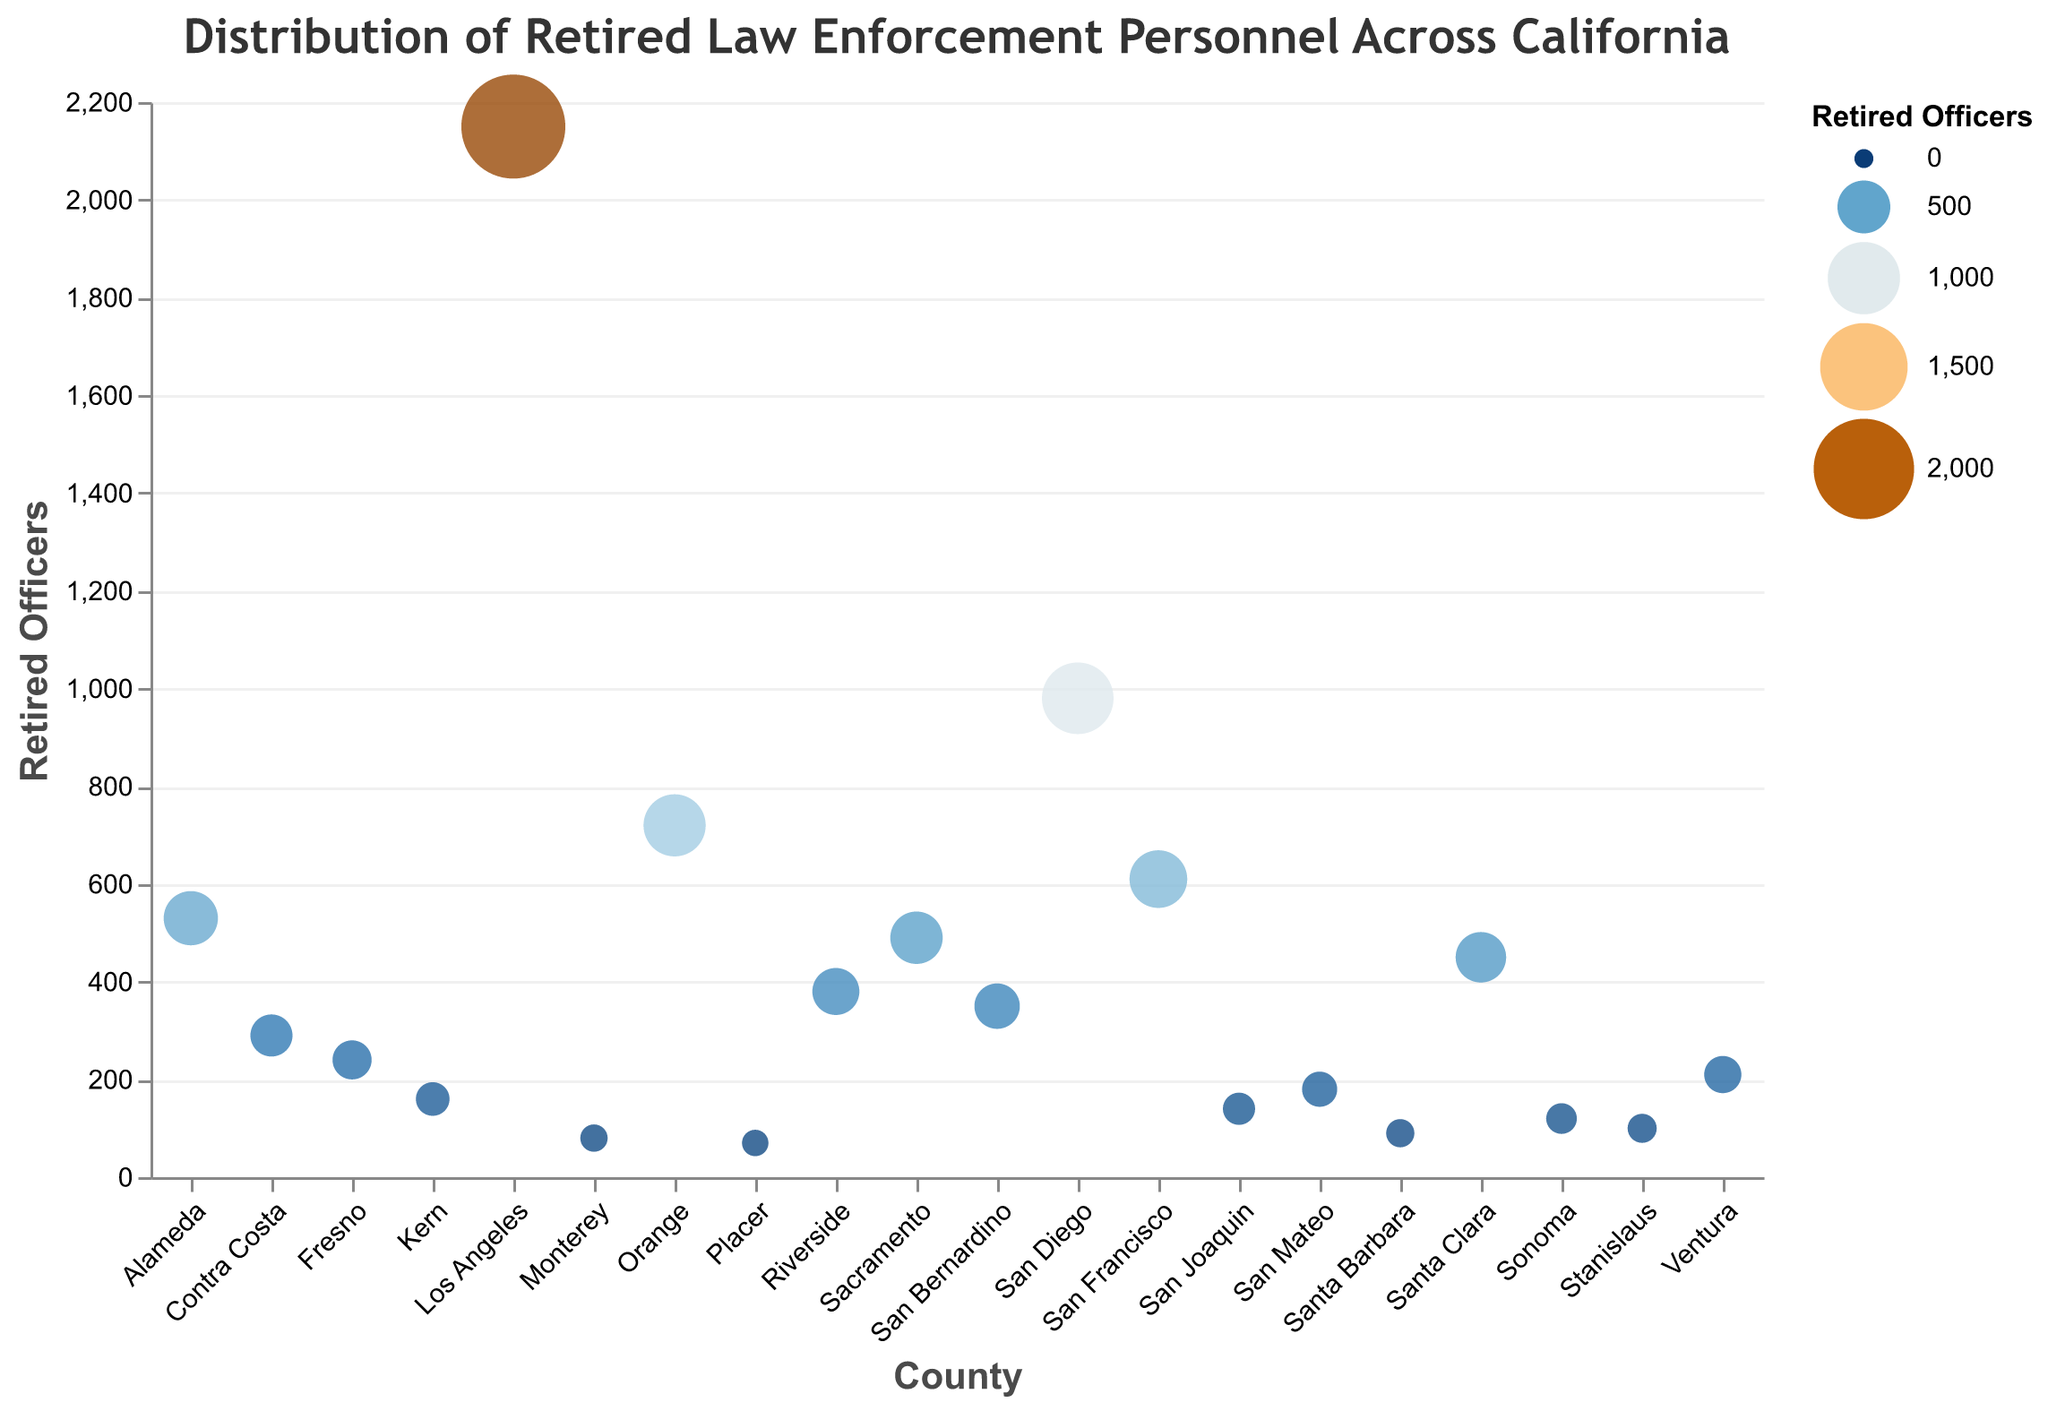What is the county with the highest number of retired law enforcement personnel? Los Angeles County has the highest number of retired law enforcement personnel with 2150 individuals, as indicated by the size and color of the corresponding circle in the plot.
Answer: Los Angeles Which county has the second-highest number of retired law enforcement personnel? The second largest circle and the second highest numerical value for retired officers correspond to San Diego County with 980 officers.
Answer: San Diego How many retired officers are there in both Orange County and San Francisco County combined? Summing up the retired officers in Orange County (720) and San Francisco County (610) gives a total of 720 + 610 = 1330 retired officers.
Answer: 1330 What is the difference in the number of retired officers between Alameda and Riverside Counties? Alameda County has 530 retired officers, while Riverside County has 380. The difference is 530 - 380 = 150.
Answer: 150 Which county among Kern, Sonoma, and Contra Costa has the fewest retired officers? Among Kern (160), Sonoma (120), and Contra Costa (290) Counties, Sonoma has the fewest retired officers with a count of 120.
Answer: Sonoma How does the number of retired law enforcement personnel in Sacramento compare to that in Santa Clara? Sacramento has 490 retired officers and Santa Clara has 450. Therefore, Sacramento has 40 more retired officers than Santa Clara.
Answer: 40 more What is the median number of retired officers across all the counties? Ordering the retired officers from least to greatest, we get: 70, 80, 90, 100, 120, 140, 160, 180, 210, 240, 290, 350, 380, 450, 490, 530, 610, 720, 980, 2150. Since there are 20 counties, the median is the average of the 10th and 11th values: (210 + 240) / 2 = 225.
Answer: 225 Which county has the smallest circle, and how many officers does it represent? Placer County has the smallest circle, representing 70 retired officers.
Answer: Placer How many counties have 200 or more retired officers? Counting the counties with 200 or more retired officers: Los Angeles (2150), San Diego (980), Orange (720), San Francisco (610), Alameda (530), Sacramento (490), Santa Clara (450), Riverside (380), San Bernardino (350), Contra Costa (290), and Fresno (240). There are a total of 11 such counties.
Answer: 11 